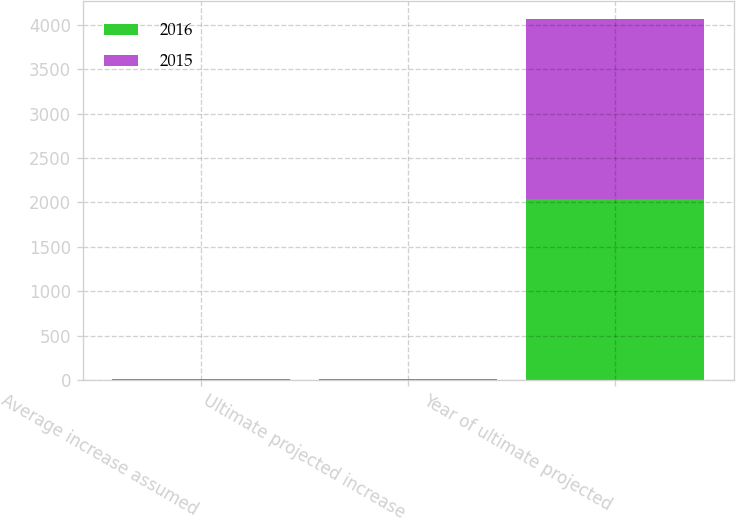Convert chart to OTSL. <chart><loc_0><loc_0><loc_500><loc_500><stacked_bar_chart><ecel><fcel>Average increase assumed<fcel>Ultimate projected increase<fcel>Year of ultimate projected<nl><fcel>2016<fcel>6<fcel>5<fcel>2039<nl><fcel>2015<fcel>6<fcel>5<fcel>2025<nl></chart> 